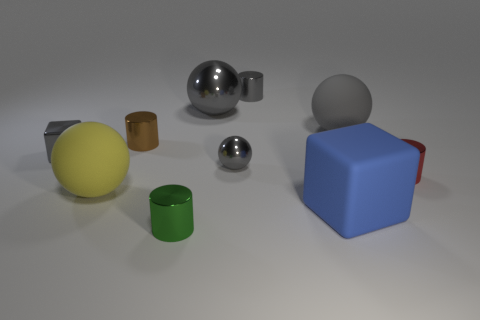Subtract all big metal balls. How many balls are left? 3 Subtract 1 blocks. How many blocks are left? 1 Subtract all yellow spheres. How many spheres are left? 3 Subtract all cubes. How many objects are left? 8 Subtract all yellow cubes. How many gray spheres are left? 3 Subtract all large blue objects. Subtract all tiny green shiny cylinders. How many objects are left? 8 Add 8 large shiny things. How many large shiny things are left? 9 Add 7 brown metal cylinders. How many brown metal cylinders exist? 8 Subtract 1 yellow spheres. How many objects are left? 9 Subtract all blue blocks. Subtract all brown cylinders. How many blocks are left? 1 